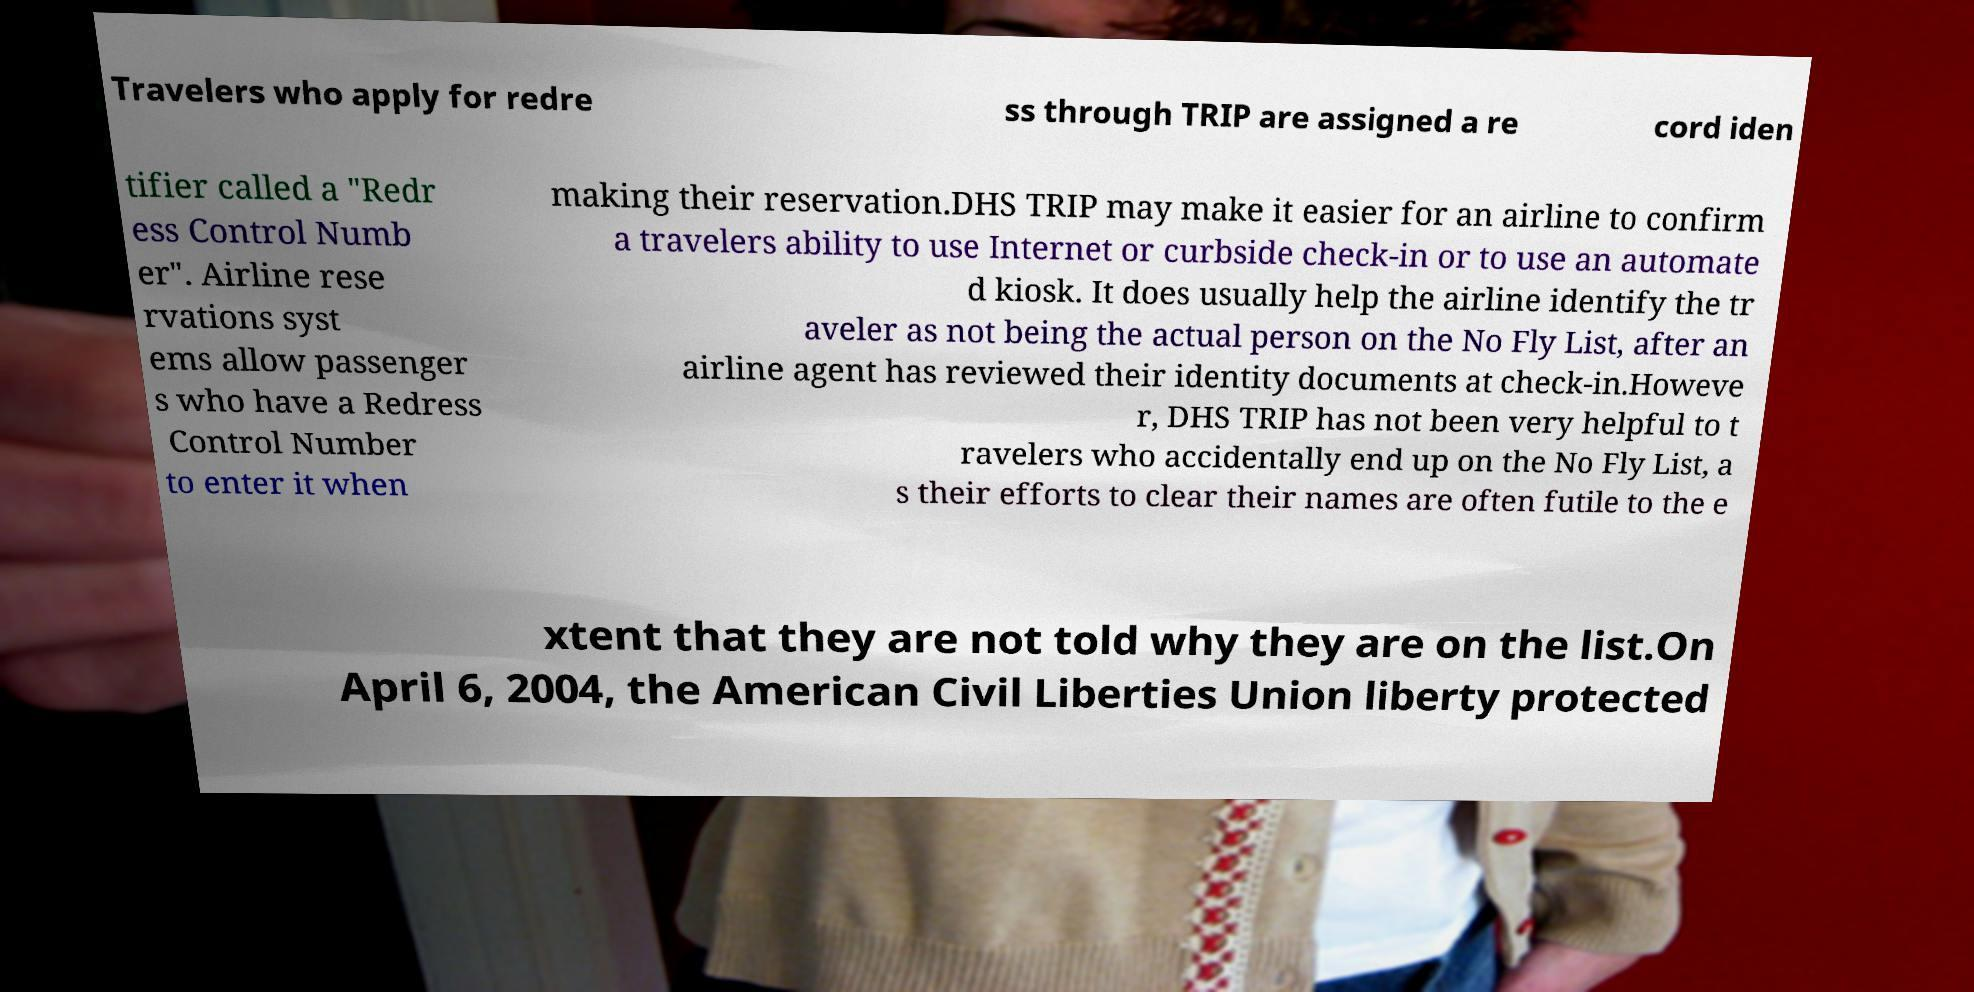I need the written content from this picture converted into text. Can you do that? Travelers who apply for redre ss through TRIP are assigned a re cord iden tifier called a "Redr ess Control Numb er". Airline rese rvations syst ems allow passenger s who have a Redress Control Number to enter it when making their reservation.DHS TRIP may make it easier for an airline to confirm a travelers ability to use Internet or curbside check-in or to use an automate d kiosk. It does usually help the airline identify the tr aveler as not being the actual person on the No Fly List, after an airline agent has reviewed their identity documents at check-in.Howeve r, DHS TRIP has not been very helpful to t ravelers who accidentally end up on the No Fly List, a s their efforts to clear their names are often futile to the e xtent that they are not told why they are on the list.On April 6, 2004, the American Civil Liberties Union liberty protected 